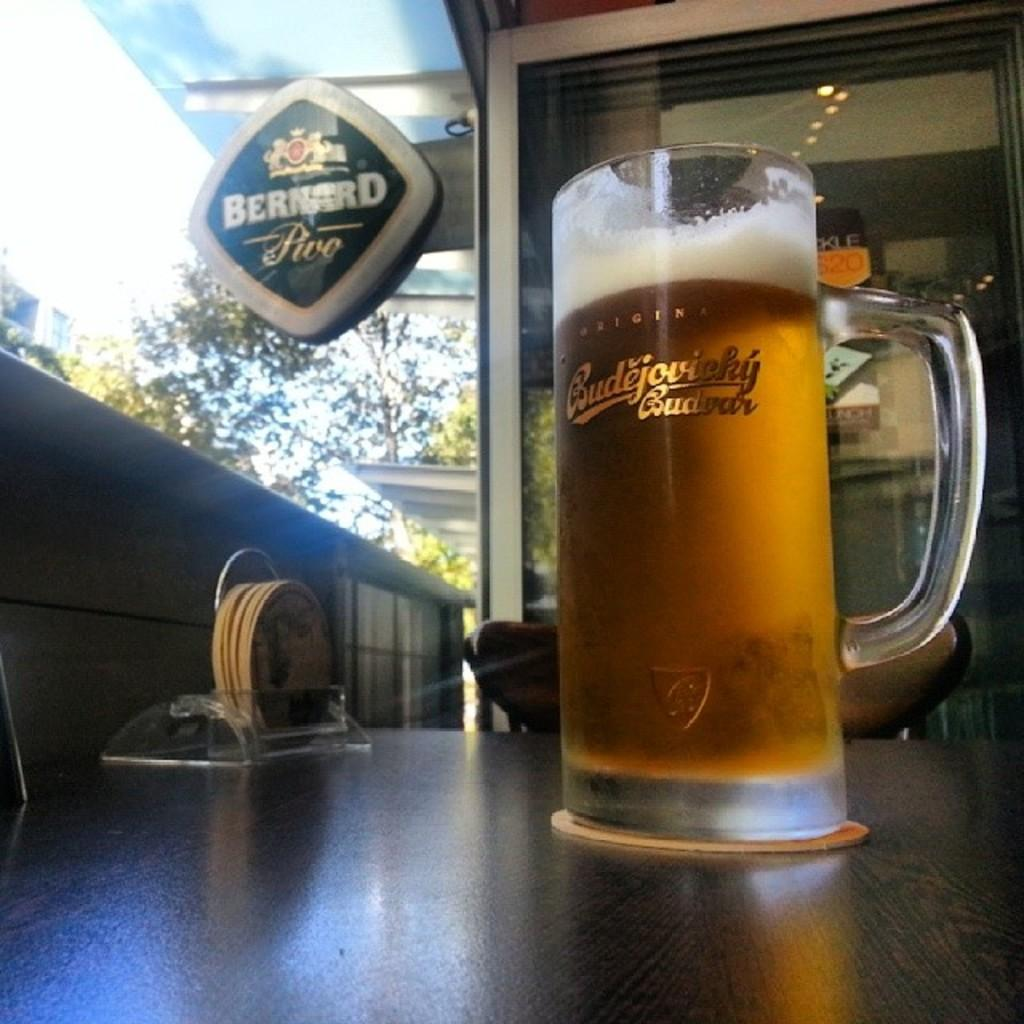Provide a one-sentence caption for the provided image. a mug of beer with the name Budejovicky. 